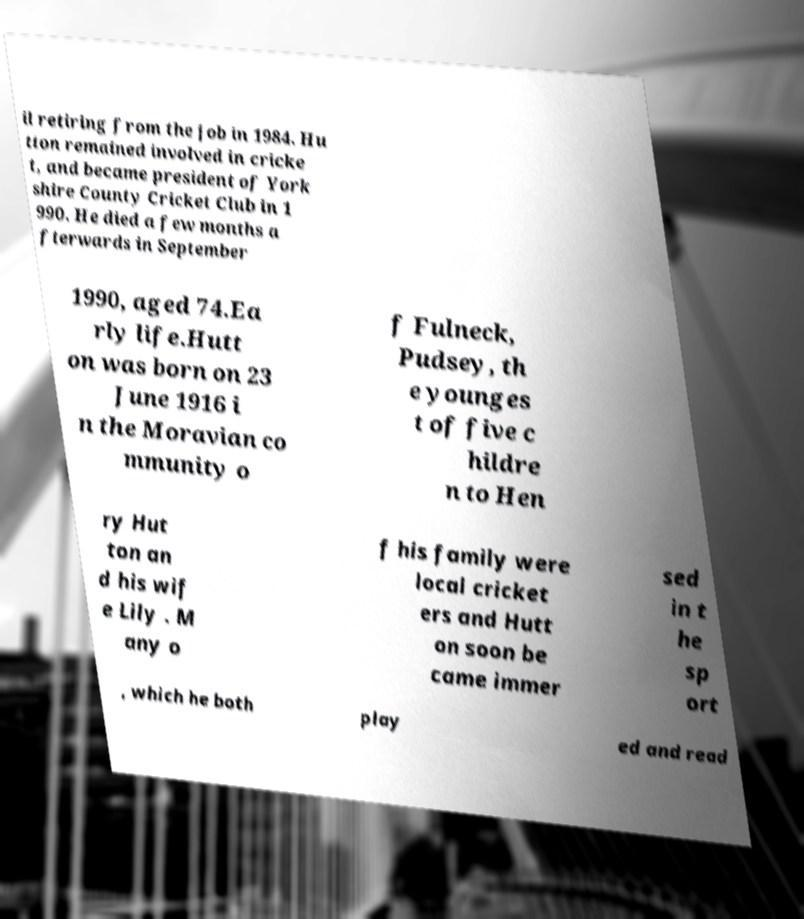I need the written content from this picture converted into text. Can you do that? il retiring from the job in 1984. Hu tton remained involved in cricke t, and became president of York shire County Cricket Club in 1 990. He died a few months a fterwards in September 1990, aged 74.Ea rly life.Hutt on was born on 23 June 1916 i n the Moravian co mmunity o f Fulneck, Pudsey, th e younges t of five c hildre n to Hen ry Hut ton an d his wif e Lily . M any o f his family were local cricket ers and Hutt on soon be came immer sed in t he sp ort , which he both play ed and read 